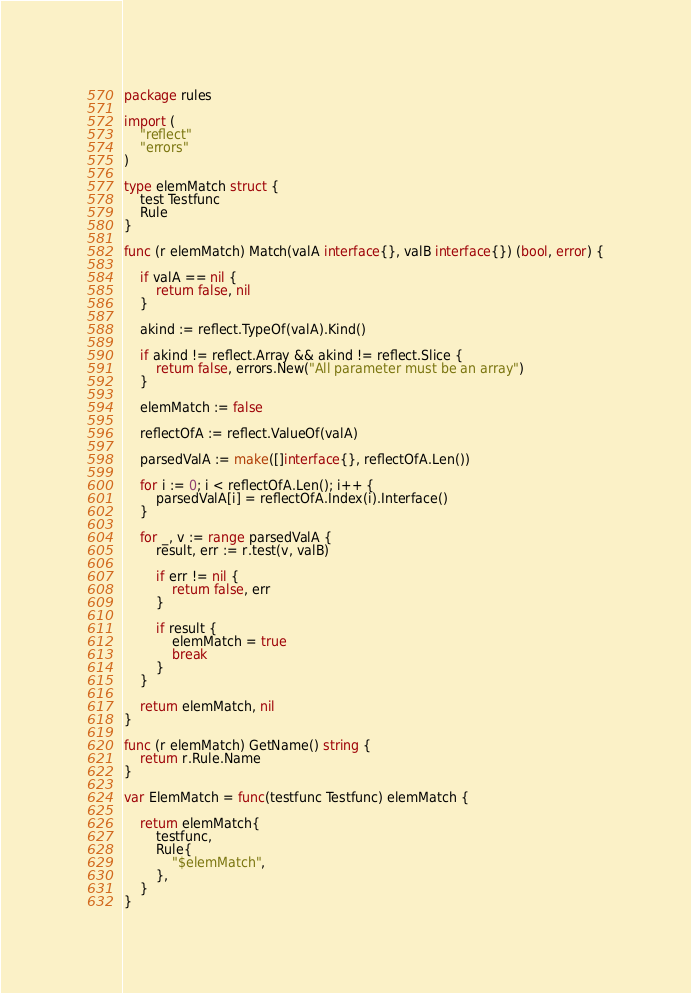<code> <loc_0><loc_0><loc_500><loc_500><_Go_>package rules

import (
	"reflect"
	"errors"
)

type elemMatch struct {
	test Testfunc
	Rule
}

func (r elemMatch) Match(valA interface{}, valB interface{}) (bool, error) {

	if valA == nil {
		return false, nil
	}

	akind := reflect.TypeOf(valA).Kind()

	if akind != reflect.Array && akind != reflect.Slice {
		return false, errors.New("All parameter must be an array")
	}

	elemMatch := false

	reflectOfA := reflect.ValueOf(valA)

	parsedValA := make([]interface{}, reflectOfA.Len())

	for i := 0; i < reflectOfA.Len(); i++ {
		parsedValA[i] = reflectOfA.Index(i).Interface()
	}

	for _, v := range parsedValA {
		result, err := r.test(v, valB)

		if err != nil {
			return false, err
		}

		if result {
			elemMatch = true
			break
		}
	}

	return elemMatch, nil
}

func (r elemMatch) GetName() string {
	return r.Rule.Name
}

var ElemMatch = func(testfunc Testfunc) elemMatch {

	return elemMatch{
		testfunc,
		Rule{
			"$elemMatch",
		},
	}
}
</code> 